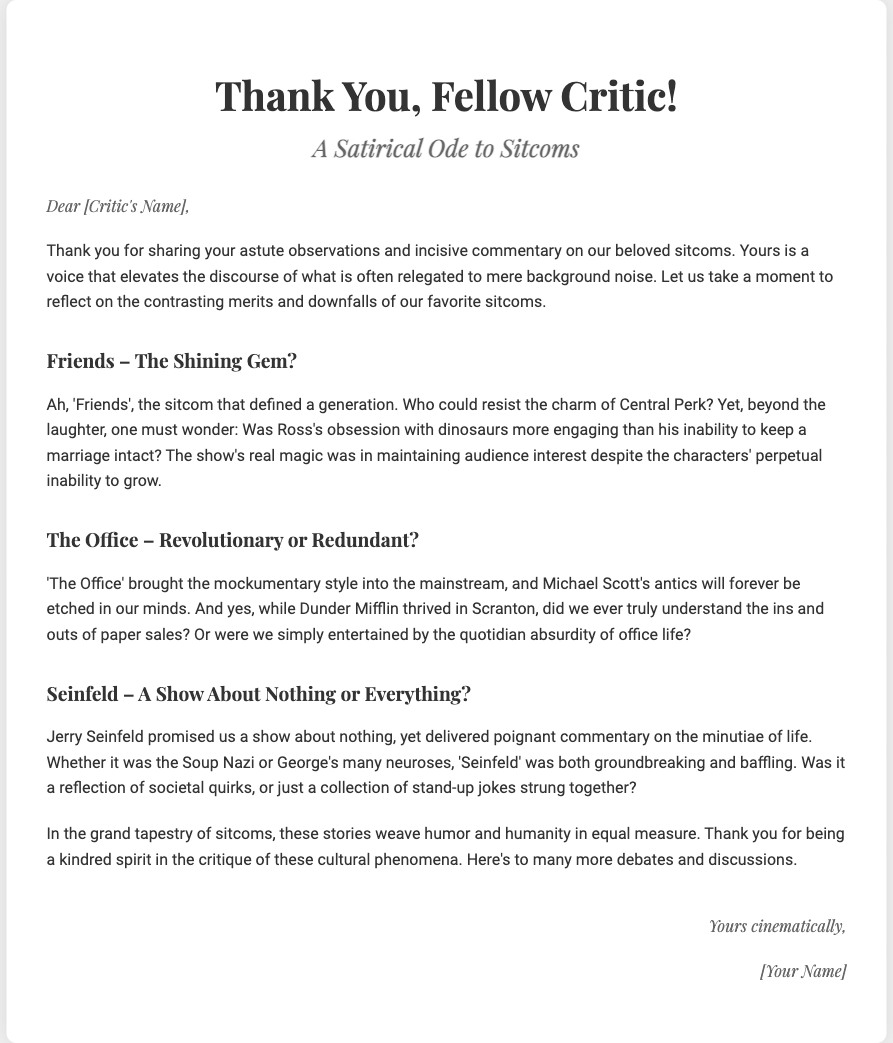What is the title of the card? The title of the card is stated prominently at the top of the document.
Answer: Thank You, Fellow Critic! Who is the card addressed to? The card includes a placeholder for the recipient's name at the beginning.
Answer: [Critic's Name] What sitcom is referred to as a "shining gem"? The document presents a contrasting perspective on various sitcoms and refers to one specifically as a "shining gem".
Answer: Friends Which sitcom is described as "revolutionary or redundant"? This phrase is directly used to discuss the merits of another sitcom in the document.
Answer: The Office What style did 'The Office' bring into the mainstream? The document highlights a significant aspect of this sitcom's influence on media.
Answer: Mockumentary What type of card is this? The structure and content are typical of a message of appreciation, unique to greeting cards.
Answer: Thank you card Who is the author of the card? The card provides a closing signature at the end with a placeholder for the author's name.
Answer: [Your Name] What is the underlying theme of the card? The card contrasts various popular sitcoms, showcasing humor and critique.
Answer: Satirical Ode to Sitcoms What is mentioned as a societal reflection in 'Seinfeld'? The document discusses the implications of humor and commentary within this sitcom.
Answer: Minutiae of life 